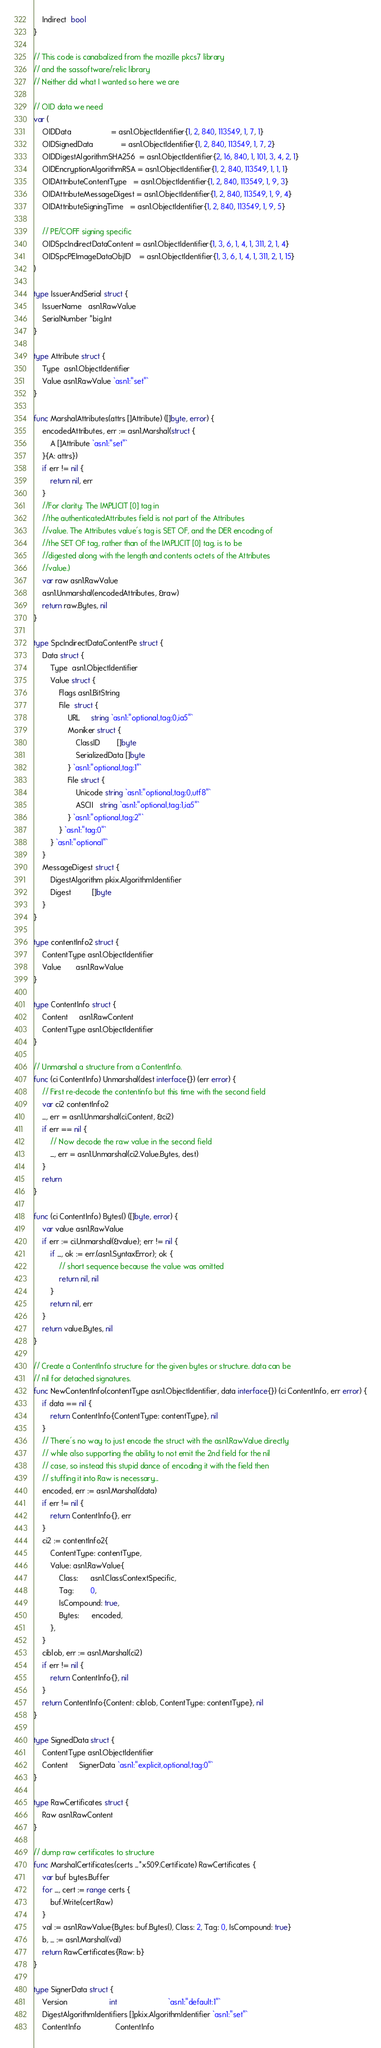Convert code to text. <code><loc_0><loc_0><loc_500><loc_500><_Go_>	Indirect  bool
}

// This code is canabalized from the mozille pkcs7 library
// and the sassoftware/relic library
// Neither did what I wanted so here we are

// OID data we need
var (
	OIDData                   = asn1.ObjectIdentifier{1, 2, 840, 113549, 1, 7, 1}
	OIDSignedData             = asn1.ObjectIdentifier{1, 2, 840, 113549, 1, 7, 2}
	OIDDigestAlgorithmSHA256  = asn1.ObjectIdentifier{2, 16, 840, 1, 101, 3, 4, 2, 1}
	OIDEncryptionAlgorithmRSA = asn1.ObjectIdentifier{1, 2, 840, 113549, 1, 1, 1}
	OIDAttributeContentType   = asn1.ObjectIdentifier{1, 2, 840, 113549, 1, 9, 3}
	OIDAttributeMessageDigest = asn1.ObjectIdentifier{1, 2, 840, 113549, 1, 9, 4}
	OIDAttributeSigningTime   = asn1.ObjectIdentifier{1, 2, 840, 113549, 1, 9, 5}

	// PE/COFF signing specific
	OIDSpcIndirectDataContent = asn1.ObjectIdentifier{1, 3, 6, 1, 4, 1, 311, 2, 1, 4}
	OIDSpcPEImageDataObjID    = asn1.ObjectIdentifier{1, 3, 6, 1, 4, 1, 311, 2, 1, 15}
)

type IssuerAndSerial struct {
	IssuerName   asn1.RawValue
	SerialNumber *big.Int
}

type Attribute struct {
	Type  asn1.ObjectIdentifier
	Value asn1.RawValue `asn1:"set"`
}

func MarshalAttributes(attrs []Attribute) ([]byte, error) {
	encodedAttributes, err := asn1.Marshal(struct {
		A []Attribute `asn1:"set"`
	}{A: attrs})
	if err != nil {
		return nil, err
	}
	//For clarity: The IMPLICIT [0] tag in
	//the authenticatedAttributes field is not part of the Attributes
	//value. The Attributes value's tag is SET OF, and the DER encoding of
	//the SET OF tag, rather than of the IMPLICIT [0] tag, is to be
	//digested along with the length and contents octets of the Attributes
	//value.)
	var raw asn1.RawValue
	asn1.Unmarshal(encodedAttributes, &raw)
	return raw.Bytes, nil
}

type SpcIndirectDataContentPe struct {
	Data struct {
		Type  asn1.ObjectIdentifier
		Value struct {
			Flags asn1.BitString
			File  struct {
				URL     string `asn1:"optional,tag:0,ia5"`
				Moniker struct {
					ClassID        []byte
					SerializedData []byte
				} `asn1:"optional,tag:1"`
				File struct {
					Unicode string `asn1:"optional,tag:0,utf8"`
					ASCII   string `asn1:"optional,tag:1,ia5"`
				} `asn1:"optional,tag:2"`
			} `asn1:"tag:0"`
		} `asn1:"optional"`
	}
	MessageDigest struct {
		DigestAlgorithm pkix.AlgorithmIdentifier
		Digest          []byte
	}
}

type contentInfo2 struct {
	ContentType asn1.ObjectIdentifier
	Value       asn1.RawValue
}

type ContentInfo struct {
	Content     asn1.RawContent
	ContentType asn1.ObjectIdentifier
}

// Unmarshal a structure from a ContentInfo.
func (ci ContentInfo) Unmarshal(dest interface{}) (err error) {
	// First re-decode the contentinfo but this time with the second field
	var ci2 contentInfo2
	_, err = asn1.Unmarshal(ci.Content, &ci2)
	if err == nil {
		// Now decode the raw value in the second field
		_, err = asn1.Unmarshal(ci2.Value.Bytes, dest)
	}
	return
}

func (ci ContentInfo) Bytes() ([]byte, error) {
	var value asn1.RawValue
	if err := ci.Unmarshal(&value); err != nil {
		if _, ok := err.(asn1.SyntaxError); ok {
			// short sequence because the value was omitted
			return nil, nil
		}
		return nil, err
	}
	return value.Bytes, nil
}

// Create a ContentInfo structure for the given bytes or structure. data can be
// nil for detached signatures.
func NewContentInfo(contentType asn1.ObjectIdentifier, data interface{}) (ci ContentInfo, err error) {
	if data == nil {
		return ContentInfo{ContentType: contentType}, nil
	}
	// There's no way to just encode the struct with the asn1.RawValue directly
	// while also supporting the ability to not emit the 2nd field for the nil
	// case, so instead this stupid dance of encoding it with the field then
	// stuffing it into Raw is necessary...
	encoded, err := asn1.Marshal(data)
	if err != nil {
		return ContentInfo{}, err
	}
	ci2 := contentInfo2{
		ContentType: contentType,
		Value: asn1.RawValue{
			Class:      asn1.ClassContextSpecific,
			Tag:        0,
			IsCompound: true,
			Bytes:      encoded,
		},
	}
	ciblob, err := asn1.Marshal(ci2)
	if err != nil {
		return ContentInfo{}, nil
	}
	return ContentInfo{Content: ciblob, ContentType: contentType}, nil
}

type SignedData struct {
	ContentType asn1.ObjectIdentifier
	Content     SignerData `asn1:"explicit,optional,tag:0"`
}

type RawCertificates struct {
	Raw asn1.RawContent
}

// dump raw certificates to structure
func MarshalCertificates(certs ...*x509.Certificate) RawCertificates {
	var buf bytes.Buffer
	for _, cert := range certs {
		buf.Write(cert.Raw)
	}
	val := asn1.RawValue{Bytes: buf.Bytes(), Class: 2, Tag: 0, IsCompound: true}
	b, _ := asn1.Marshal(val)
	return RawCertificates{Raw: b}
}

type SignerData struct {
	Version                    int                        `asn1:"default:1"`
	DigestAlgorithmIdentifiers []pkix.AlgorithmIdentifier `asn1:"set"`
	ContentInfo                ContentInfo</code> 